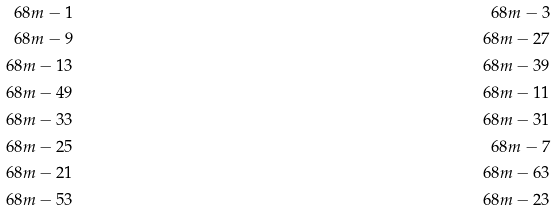Convert formula to latex. <formula><loc_0><loc_0><loc_500><loc_500>6 8 m - 1 & & 6 8 m - 3 \\ 6 8 m - 9 & & 6 8 m - 2 7 \\ 6 8 m - 1 3 & & 6 8 m - 3 9 \\ 6 8 m - 4 9 & & 6 8 m - 1 1 \\ 6 8 m - 3 3 & & 6 8 m - 3 1 \\ 6 8 m - 2 5 & & 6 8 m - 7 \\ 6 8 m - 2 1 & & 6 8 m - 6 3 \\ 6 8 m - 5 3 & & 6 8 m - 2 3</formula> 